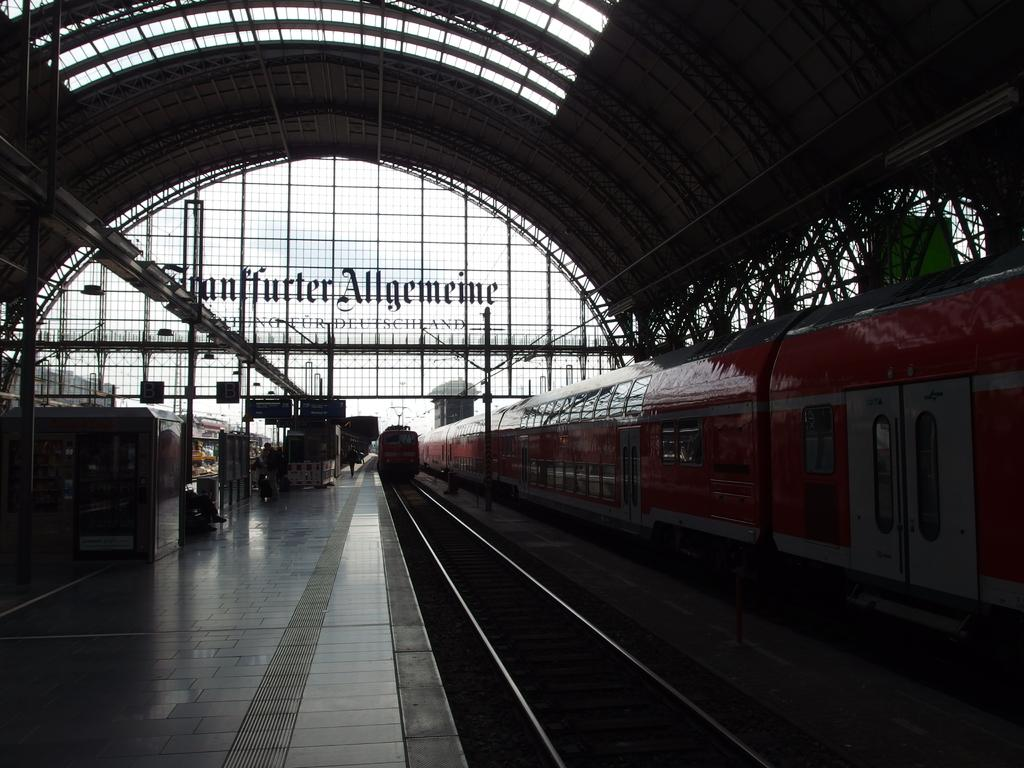What type of location is depicted in the image? The image is an inside view of a railway station. What can be seen on the ground level in the image? There is a platform visible in the image. What is located near the platform in the image? Railway tracks are present in the image. What mode of transportation can be seen in the image? Trains are visible in the image. Where are the toys and pail stored in the image? There are no toys or pail present in the image. Can you describe the mother's interaction with the children in the image? There are no children or mother present in the image. 